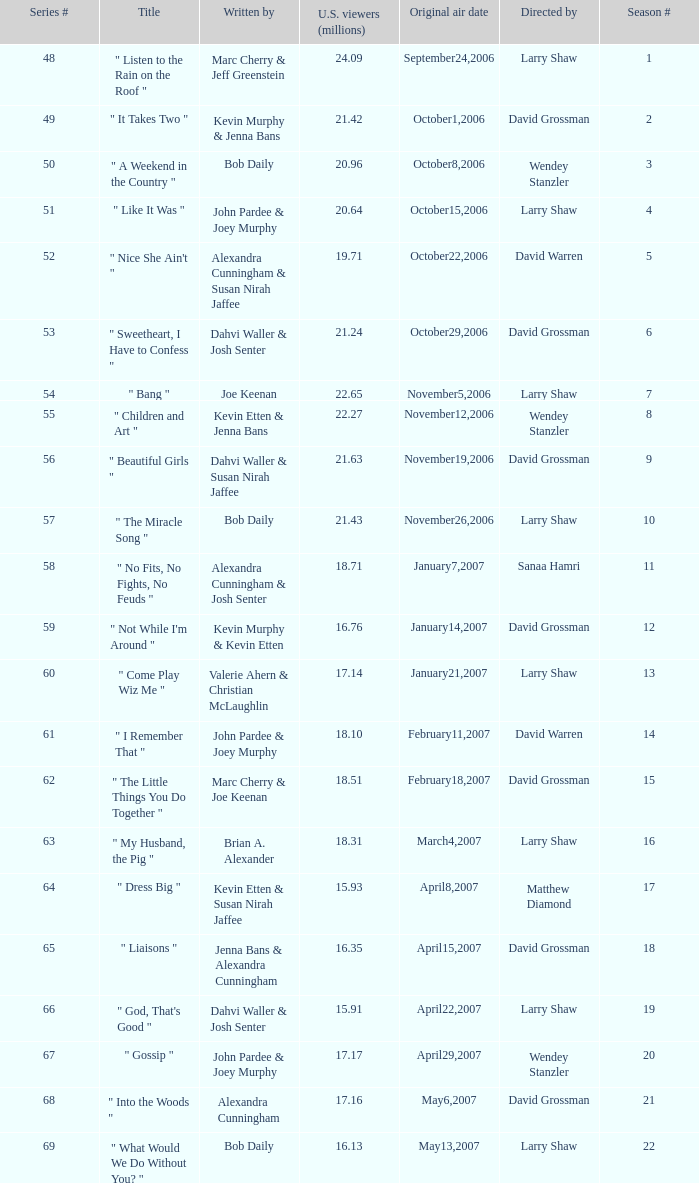Would you be able to parse every entry in this table? {'header': ['Series #', 'Title', 'Written by', 'U.S. viewers (millions)', 'Original air date', 'Directed by', 'Season #'], 'rows': [['48', '" Listen to the Rain on the Roof "', 'Marc Cherry & Jeff Greenstein', '24.09', 'September24,2006', 'Larry Shaw', '1'], ['49', '" It Takes Two "', 'Kevin Murphy & Jenna Bans', '21.42', 'October1,2006', 'David Grossman', '2'], ['50', '" A Weekend in the Country "', 'Bob Daily', '20.96', 'October8,2006', 'Wendey Stanzler', '3'], ['51', '" Like It Was "', 'John Pardee & Joey Murphy', '20.64', 'October15,2006', 'Larry Shaw', '4'], ['52', '" Nice She Ain\'t "', 'Alexandra Cunningham & Susan Nirah Jaffee', '19.71', 'October22,2006', 'David Warren', '5'], ['53', '" Sweetheart, I Have to Confess "', 'Dahvi Waller & Josh Senter', '21.24', 'October29,2006', 'David Grossman', '6'], ['54', '" Bang "', 'Joe Keenan', '22.65', 'November5,2006', 'Larry Shaw', '7'], ['55', '" Children and Art "', 'Kevin Etten & Jenna Bans', '22.27', 'November12,2006', 'Wendey Stanzler', '8'], ['56', '" Beautiful Girls "', 'Dahvi Waller & Susan Nirah Jaffee', '21.63', 'November19,2006', 'David Grossman', '9'], ['57', '" The Miracle Song "', 'Bob Daily', '21.43', 'November26,2006', 'Larry Shaw', '10'], ['58', '" No Fits, No Fights, No Feuds "', 'Alexandra Cunningham & Josh Senter', '18.71', 'January7,2007', 'Sanaa Hamri', '11'], ['59', '" Not While I\'m Around "', 'Kevin Murphy & Kevin Etten', '16.76', 'January14,2007', 'David Grossman', '12'], ['60', '" Come Play Wiz Me "', 'Valerie Ahern & Christian McLaughlin', '17.14', 'January21,2007', 'Larry Shaw', '13'], ['61', '" I Remember That "', 'John Pardee & Joey Murphy', '18.10', 'February11,2007', 'David Warren', '14'], ['62', '" The Little Things You Do Together "', 'Marc Cherry & Joe Keenan', '18.51', 'February18,2007', 'David Grossman', '15'], ['63', '" My Husband, the Pig "', 'Brian A. Alexander', '18.31', 'March4,2007', 'Larry Shaw', '16'], ['64', '" Dress Big "', 'Kevin Etten & Susan Nirah Jaffee', '15.93', 'April8,2007', 'Matthew Diamond', '17'], ['65', '" Liaisons "', 'Jenna Bans & Alexandra Cunningham', '16.35', 'April15,2007', 'David Grossman', '18'], ['66', '" God, That\'s Good "', 'Dahvi Waller & Josh Senter', '15.91', 'April22,2007', 'Larry Shaw', '19'], ['67', '" Gossip "', 'John Pardee & Joey Murphy', '17.17', 'April29,2007', 'Wendey Stanzler', '20'], ['68', '" Into the Woods "', 'Alexandra Cunningham', '17.16', 'May6,2007', 'David Grossman', '21'], ['69', '" What Would We Do Without You? "', 'Bob Daily', '16.13', 'May13,2007', 'Larry Shaw', '22']]} What series number garnered 20.64 million viewers? 51.0. 